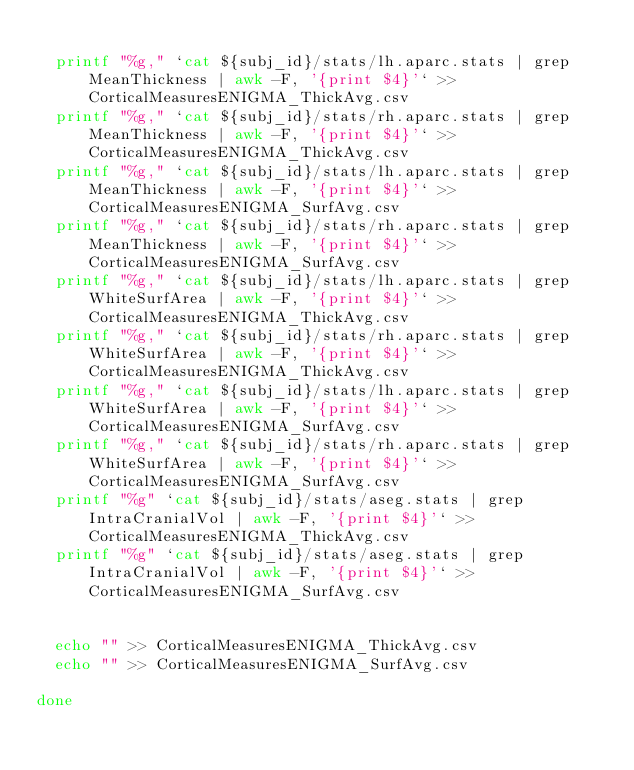<code> <loc_0><loc_0><loc_500><loc_500><_Bash_>
  printf "%g," `cat ${subj_id}/stats/lh.aparc.stats | grep MeanThickness | awk -F, '{print $4}'` >> CorticalMeasuresENIGMA_ThickAvg.csv
  printf "%g," `cat ${subj_id}/stats/rh.aparc.stats | grep MeanThickness | awk -F, '{print $4}'` >> CorticalMeasuresENIGMA_ThickAvg.csv
  printf "%g," `cat ${subj_id}/stats/lh.aparc.stats | grep MeanThickness | awk -F, '{print $4}'` >> CorticalMeasuresENIGMA_SurfAvg.csv
  printf "%g," `cat ${subj_id}/stats/rh.aparc.stats | grep MeanThickness | awk -F, '{print $4}'` >> CorticalMeasuresENIGMA_SurfAvg.csv
  printf "%g," `cat ${subj_id}/stats/lh.aparc.stats | grep WhiteSurfArea | awk -F, '{print $4}'` >> CorticalMeasuresENIGMA_ThickAvg.csv
  printf "%g," `cat ${subj_id}/stats/rh.aparc.stats | grep WhiteSurfArea | awk -F, '{print $4}'` >> CorticalMeasuresENIGMA_ThickAvg.csv
  printf "%g," `cat ${subj_id}/stats/lh.aparc.stats | grep WhiteSurfArea | awk -F, '{print $4}'` >> CorticalMeasuresENIGMA_SurfAvg.csv
  printf "%g," `cat ${subj_id}/stats/rh.aparc.stats | grep WhiteSurfArea | awk -F, '{print $4}'` >> CorticalMeasuresENIGMA_SurfAvg.csv
  printf "%g" `cat ${subj_id}/stats/aseg.stats | grep IntraCranialVol | awk -F, '{print $4}'` >> CorticalMeasuresENIGMA_ThickAvg.csv
  printf "%g" `cat ${subj_id}/stats/aseg.stats | grep IntraCranialVol | awk -F, '{print $4}'` >> CorticalMeasuresENIGMA_SurfAvg.csv


  echo "" >> CorticalMeasuresENIGMA_ThickAvg.csv
  echo "" >> CorticalMeasuresENIGMA_SurfAvg.csv

done
</code> 